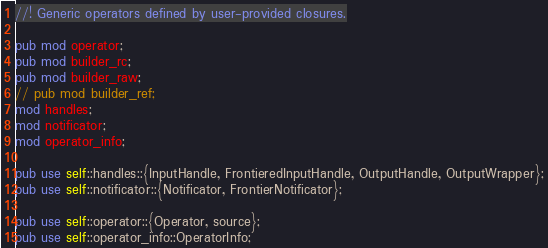<code> <loc_0><loc_0><loc_500><loc_500><_Rust_>//! Generic operators defined by user-provided closures.

pub mod operator;
pub mod builder_rc;
pub mod builder_raw;
// pub mod builder_ref;
mod handles;
mod notificator;
mod operator_info;

pub use self::handles::{InputHandle, FrontieredInputHandle, OutputHandle, OutputWrapper};
pub use self::notificator::{Notificator, FrontierNotificator};

pub use self::operator::{Operator, source};
pub use self::operator_info::OperatorInfo;
</code> 